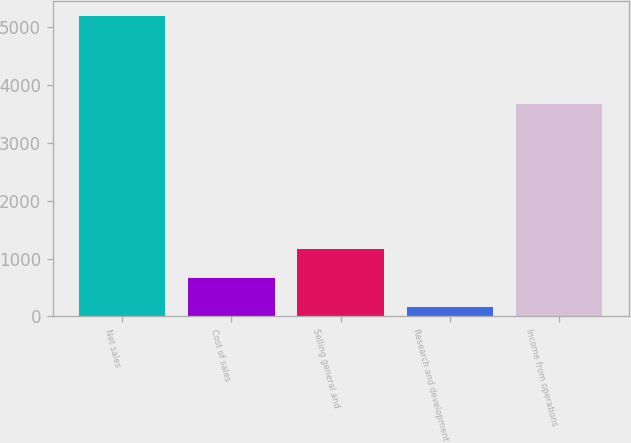Convert chart to OTSL. <chart><loc_0><loc_0><loc_500><loc_500><bar_chart><fcel>Net sales<fcel>Cost of sales<fcel>Selling general and<fcel>Research and development<fcel>Income from operations<nl><fcel>5186<fcel>659<fcel>1162<fcel>156<fcel>3663<nl></chart> 